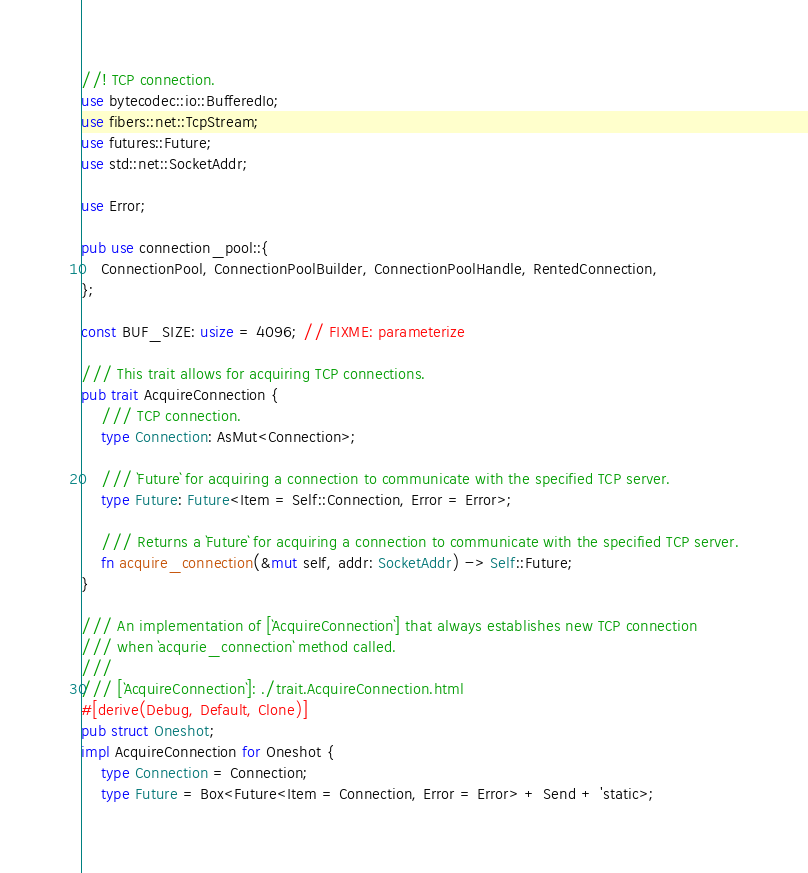Convert code to text. <code><loc_0><loc_0><loc_500><loc_500><_Rust_>//! TCP connection.
use bytecodec::io::BufferedIo;
use fibers::net::TcpStream;
use futures::Future;
use std::net::SocketAddr;

use Error;

pub use connection_pool::{
    ConnectionPool, ConnectionPoolBuilder, ConnectionPoolHandle, RentedConnection,
};

const BUF_SIZE: usize = 4096; // FIXME: parameterize

/// This trait allows for acquiring TCP connections.
pub trait AcquireConnection {
    /// TCP connection.
    type Connection: AsMut<Connection>;

    /// `Future` for acquiring a connection to communicate with the specified TCP server.
    type Future: Future<Item = Self::Connection, Error = Error>;

    /// Returns a `Future` for acquiring a connection to communicate with the specified TCP server.
    fn acquire_connection(&mut self, addr: SocketAddr) -> Self::Future;
}

/// An implementation of [`AcquireConnection`] that always establishes new TCP connection
/// when `acqurie_connection` method called.
///
/// [`AcquireConnection`]: ./trait.AcquireConnection.html
#[derive(Debug, Default, Clone)]
pub struct Oneshot;
impl AcquireConnection for Oneshot {
    type Connection = Connection;
    type Future = Box<Future<Item = Connection, Error = Error> + Send + 'static>;
</code> 